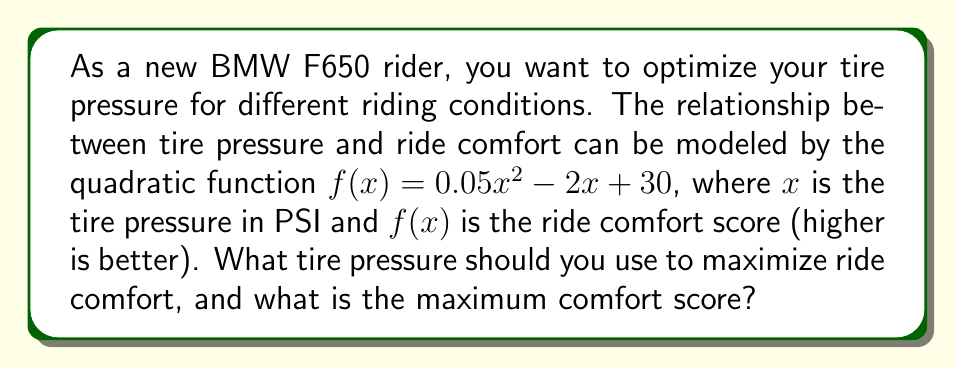Show me your answer to this math problem. To find the optimal tire pressure for maximum ride comfort, we need to find the vertex of the quadratic function. The vertex represents the maximum point of the parabola since the coefficient of $x^2$ is positive (0.05 > 0).

For a quadratic function in the form $f(x) = ax^2 + bx + c$, the x-coordinate of the vertex is given by $x = -\frac{b}{2a}$.

In this case:
$a = 0.05$
$b = -2$
$c = 30$

Let's calculate the x-coordinate of the vertex:

$x = -\frac{b}{2a} = -\frac{-2}{2(0.05)} = \frac{2}{0.1} = 20$

So, the optimal tire pressure is 20 PSI.

To find the maximum comfort score, we need to evaluate $f(20)$:

$f(20) = 0.05(20)^2 - 2(20) + 30$
$= 0.05(400) - 40 + 30$
$= 20 - 40 + 30$
$= 10$

Therefore, the maximum comfort score is 10.
Answer: The optimal tire pressure is 20 PSI, and the maximum comfort score is 10. 